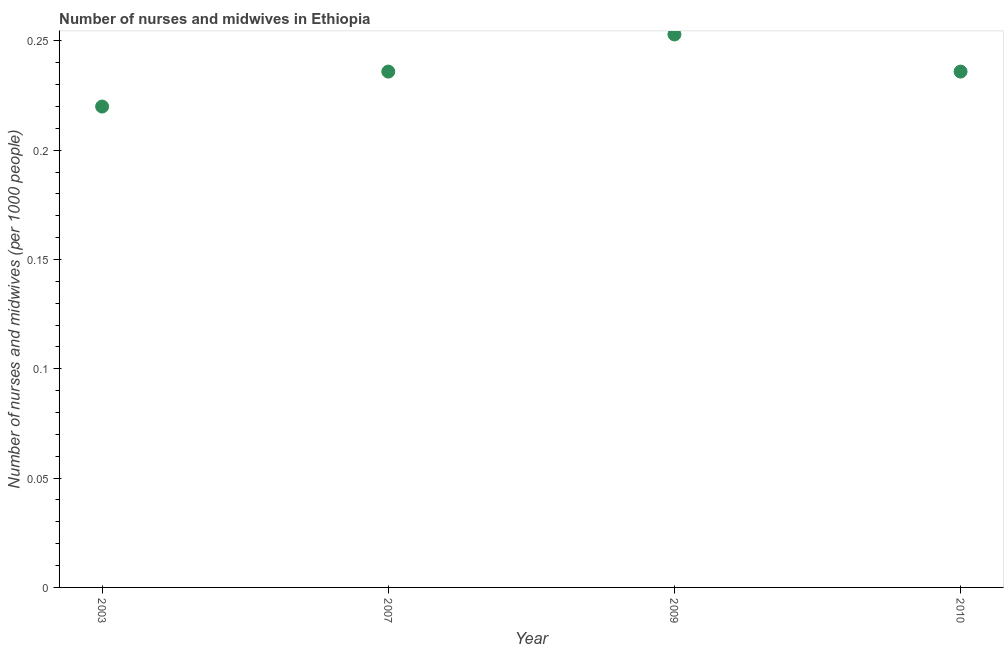What is the number of nurses and midwives in 2010?
Your answer should be compact. 0.24. Across all years, what is the maximum number of nurses and midwives?
Provide a short and direct response. 0.25. Across all years, what is the minimum number of nurses and midwives?
Your answer should be very brief. 0.22. In which year was the number of nurses and midwives maximum?
Give a very brief answer. 2009. In which year was the number of nurses and midwives minimum?
Your answer should be compact. 2003. What is the sum of the number of nurses and midwives?
Offer a very short reply. 0.94. What is the difference between the number of nurses and midwives in 2009 and 2010?
Your response must be concise. 0.02. What is the average number of nurses and midwives per year?
Give a very brief answer. 0.24. What is the median number of nurses and midwives?
Offer a very short reply. 0.24. Do a majority of the years between 2003 and 2010 (inclusive) have number of nurses and midwives greater than 0.05 ?
Provide a succinct answer. Yes. What is the ratio of the number of nurses and midwives in 2003 to that in 2010?
Provide a succinct answer. 0.93. What is the difference between the highest and the second highest number of nurses and midwives?
Offer a very short reply. 0.02. What is the difference between the highest and the lowest number of nurses and midwives?
Keep it short and to the point. 0.03. In how many years, is the number of nurses and midwives greater than the average number of nurses and midwives taken over all years?
Provide a succinct answer. 1. How many years are there in the graph?
Offer a terse response. 4. What is the difference between two consecutive major ticks on the Y-axis?
Make the answer very short. 0.05. Does the graph contain any zero values?
Your answer should be very brief. No. What is the title of the graph?
Provide a short and direct response. Number of nurses and midwives in Ethiopia. What is the label or title of the Y-axis?
Offer a very short reply. Number of nurses and midwives (per 1000 people). What is the Number of nurses and midwives (per 1000 people) in 2003?
Keep it short and to the point. 0.22. What is the Number of nurses and midwives (per 1000 people) in 2007?
Make the answer very short. 0.24. What is the Number of nurses and midwives (per 1000 people) in 2009?
Offer a very short reply. 0.25. What is the Number of nurses and midwives (per 1000 people) in 2010?
Make the answer very short. 0.24. What is the difference between the Number of nurses and midwives (per 1000 people) in 2003 and 2007?
Your response must be concise. -0.02. What is the difference between the Number of nurses and midwives (per 1000 people) in 2003 and 2009?
Provide a short and direct response. -0.03. What is the difference between the Number of nurses and midwives (per 1000 people) in 2003 and 2010?
Keep it short and to the point. -0.02. What is the difference between the Number of nurses and midwives (per 1000 people) in 2007 and 2009?
Provide a succinct answer. -0.02. What is the difference between the Number of nurses and midwives (per 1000 people) in 2009 and 2010?
Provide a succinct answer. 0.02. What is the ratio of the Number of nurses and midwives (per 1000 people) in 2003 to that in 2007?
Give a very brief answer. 0.93. What is the ratio of the Number of nurses and midwives (per 1000 people) in 2003 to that in 2009?
Offer a terse response. 0.87. What is the ratio of the Number of nurses and midwives (per 1000 people) in 2003 to that in 2010?
Your answer should be compact. 0.93. What is the ratio of the Number of nurses and midwives (per 1000 people) in 2007 to that in 2009?
Keep it short and to the point. 0.93. What is the ratio of the Number of nurses and midwives (per 1000 people) in 2009 to that in 2010?
Provide a succinct answer. 1.07. 